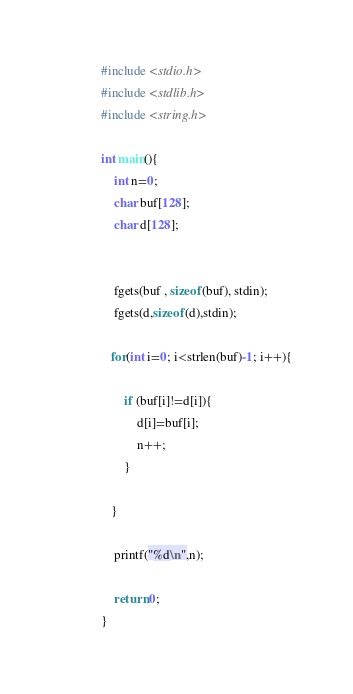<code> <loc_0><loc_0><loc_500><loc_500><_C_>#include <stdio.h>
#include <stdlib.h>
#include <string.h>

int main(){
    int n=0;
    char buf[128];
    char d[128];

   
    fgets(buf , sizeof(buf), stdin);
    fgets(d,sizeof(d),stdin);

   for(int i=0; i<strlen(buf)-1; i++){
       
       if (buf[i]!=d[i]){
           d[i]=buf[i];
           n++;
       }

   }

    printf("%d\n",n);

    return 0;
}</code> 